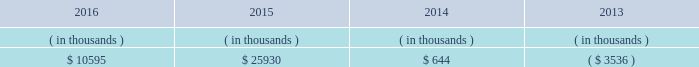Entergy mississippi , inc .
Management 2019s financial discussion and analysis entergy mississippi 2019s receivables from or ( payables to ) the money pool were as follows as of december 31 for each of the following years. .
See note 4 to the financial statements for a description of the money pool .
Entergy mississippi has four separate credit facilities in the aggregate amount of $ 102.5 million scheduled to expire may 2017 .
No borrowings were outstanding under the credit facilities as of december 31 , 2016 .
In addition , entergy mississippi is a party to an uncommitted letter of credit facility as a means to post collateral to support its obligations under miso .
As of december 31 , 2016 , a $ 7.1 million letter of credit was outstanding under entergy mississippi 2019s uncommitted letter of credit facility .
See note 4 to the financial statements for additional discussion of the credit facilities .
Entergy mississippi obtained authorizations from the ferc through october 2017 for short-term borrowings not to exceed an aggregate amount of $ 175 million at any time outstanding and long-term borrowings and security issuances .
See note 4 to the financial statements for further discussion of entergy mississippi 2019s short-term borrowing limits .
State and local rate regulation and fuel-cost recovery the rates that entergy mississippi charges for electricity significantly influence its financial position , results of operations , and liquidity .
Entergy mississippi is regulated and the rates charged to its customers are determined in regulatory proceedings .
A governmental agency , the mpsc , is primarily responsible for approval of the rates charged to customers .
Formula rate plan in june 2014 , entergy mississippi filed its first general rate case before the mpsc in almost 12 years .
The rate filing laid out entergy mississippi 2019s plans for improving reliability , modernizing the grid , maintaining its workforce , stabilizing rates , utilizing new technologies , and attracting new industry to its service territory .
Entergy mississippi requested a net increase in revenue of $ 49 million for bills rendered during calendar year 2015 , including $ 30 million resulting from new depreciation rates to update the estimated service life of assets .
In addition , the filing proposed , among other things : 1 ) realigning cost recovery of the attala and hinds power plant acquisitions from the power management rider to base rates ; 2 ) including certain miso-related revenues and expenses in the power management rider ; 3 ) power management rider changes that reflect the changes in costs and revenues that will accompany entergy mississippi 2019s withdrawal from participation in the system agreement ; and 4 ) a formula rate plan forward test year to allow for known changes in expenses and revenues for the rate effective period .
Entergy mississippi proposed maintaining the current authorized return on common equity of 10.59% ( 10.59 % ) .
In october 2014 , entergy mississippi and the mississippi public utilities staff entered into and filed joint stipulations that addressed the majority of issues in the proceeding .
The stipulations provided for : 2022 an approximate $ 16 million net increase in revenues , which reflected an agreed upon 10.07% ( 10.07 % ) return on common equity ; 2022 revision of entergy mississippi 2019s formula rate plan by providing entergy mississippi with the ability to reflect known and measurable changes to historical rate base and certain expense amounts ; resolving uncertainty around and obviating the need for an additional rate filing in connection with entergy mississippi 2019s withdrawal from participation in the system agreement ; updating depreciation rates ; and moving costs associated with the attala and hinds generating plants from the power management rider to base rates; .
What is the net change in entergy mississippi 2019s receivables from the money pool from 2015 to 2016? 
Computations: (10595 - 25930)
Answer: -15335.0. 